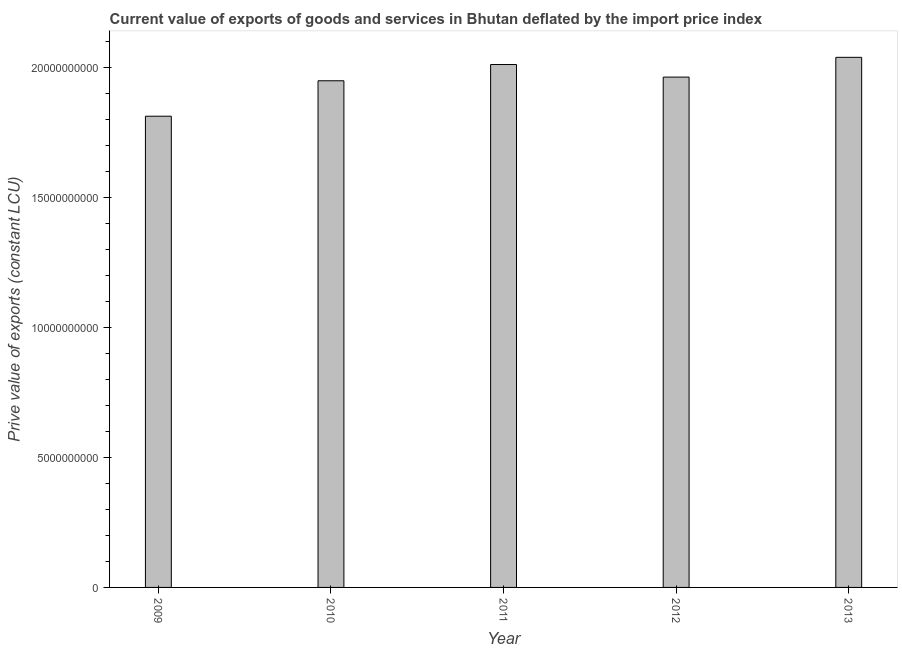What is the title of the graph?
Your answer should be very brief. Current value of exports of goods and services in Bhutan deflated by the import price index. What is the label or title of the Y-axis?
Your response must be concise. Prive value of exports (constant LCU). What is the price value of exports in 2011?
Provide a succinct answer. 2.01e+1. Across all years, what is the maximum price value of exports?
Make the answer very short. 2.04e+1. Across all years, what is the minimum price value of exports?
Your answer should be very brief. 1.81e+1. In which year was the price value of exports maximum?
Give a very brief answer. 2013. What is the sum of the price value of exports?
Offer a terse response. 9.78e+1. What is the difference between the price value of exports in 2009 and 2011?
Provide a short and direct response. -1.99e+09. What is the average price value of exports per year?
Your answer should be very brief. 1.96e+1. What is the median price value of exports?
Keep it short and to the point. 1.96e+1. Do a majority of the years between 2009 and 2010 (inclusive) have price value of exports greater than 17000000000 LCU?
Provide a short and direct response. Yes. What is the ratio of the price value of exports in 2009 to that in 2011?
Offer a very short reply. 0.9. Is the price value of exports in 2011 less than that in 2012?
Your answer should be compact. No. Is the difference between the price value of exports in 2010 and 2012 greater than the difference between any two years?
Your answer should be very brief. No. What is the difference between the highest and the second highest price value of exports?
Offer a terse response. 2.77e+08. What is the difference between the highest and the lowest price value of exports?
Your answer should be very brief. 2.26e+09. How many years are there in the graph?
Make the answer very short. 5. What is the Prive value of exports (constant LCU) of 2009?
Make the answer very short. 1.81e+1. What is the Prive value of exports (constant LCU) of 2010?
Give a very brief answer. 1.95e+1. What is the Prive value of exports (constant LCU) of 2011?
Give a very brief answer. 2.01e+1. What is the Prive value of exports (constant LCU) in 2012?
Keep it short and to the point. 1.96e+1. What is the Prive value of exports (constant LCU) in 2013?
Your answer should be compact. 2.04e+1. What is the difference between the Prive value of exports (constant LCU) in 2009 and 2010?
Offer a terse response. -1.36e+09. What is the difference between the Prive value of exports (constant LCU) in 2009 and 2011?
Give a very brief answer. -1.99e+09. What is the difference between the Prive value of exports (constant LCU) in 2009 and 2012?
Give a very brief answer. -1.50e+09. What is the difference between the Prive value of exports (constant LCU) in 2009 and 2013?
Keep it short and to the point. -2.26e+09. What is the difference between the Prive value of exports (constant LCU) in 2010 and 2011?
Ensure brevity in your answer.  -6.25e+08. What is the difference between the Prive value of exports (constant LCU) in 2010 and 2012?
Your answer should be compact. -1.41e+08. What is the difference between the Prive value of exports (constant LCU) in 2010 and 2013?
Offer a terse response. -9.02e+08. What is the difference between the Prive value of exports (constant LCU) in 2011 and 2012?
Provide a succinct answer. 4.83e+08. What is the difference between the Prive value of exports (constant LCU) in 2011 and 2013?
Ensure brevity in your answer.  -2.77e+08. What is the difference between the Prive value of exports (constant LCU) in 2012 and 2013?
Make the answer very short. -7.60e+08. What is the ratio of the Prive value of exports (constant LCU) in 2009 to that in 2011?
Keep it short and to the point. 0.9. What is the ratio of the Prive value of exports (constant LCU) in 2009 to that in 2012?
Your response must be concise. 0.92. What is the ratio of the Prive value of exports (constant LCU) in 2009 to that in 2013?
Provide a succinct answer. 0.89. What is the ratio of the Prive value of exports (constant LCU) in 2010 to that in 2012?
Your answer should be compact. 0.99. What is the ratio of the Prive value of exports (constant LCU) in 2010 to that in 2013?
Provide a short and direct response. 0.96. What is the ratio of the Prive value of exports (constant LCU) in 2011 to that in 2012?
Make the answer very short. 1.02. What is the ratio of the Prive value of exports (constant LCU) in 2011 to that in 2013?
Provide a succinct answer. 0.99. What is the ratio of the Prive value of exports (constant LCU) in 2012 to that in 2013?
Your answer should be compact. 0.96. 